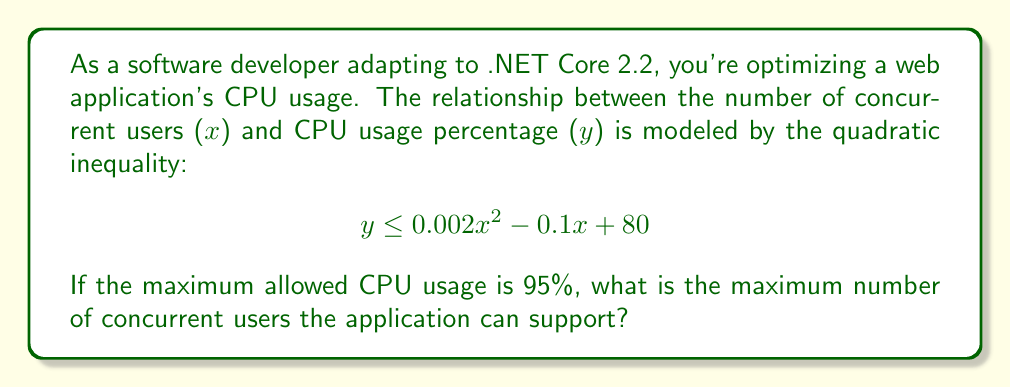Could you help me with this problem? To solve this problem, we need to follow these steps:

1) We're looking for the maximum value of x that satisfies the inequality when y = 95 (maximum CPU usage). So we can rewrite the inequality as an equation:

   $$ 95 = 0.002x^2 - 0.1x + 80 $$

2) Rearrange the equation to standard form:

   $$ 0.002x^2 - 0.1x - 15 = 0 $$

3) This is a quadratic equation. We can solve it using the quadratic formula:

   $$ x = \frac{-b \pm \sqrt{b^2 - 4ac}}{2a} $$

   Where $a = 0.002$, $b = -0.1$, and $c = -15$

4) Substituting these values:

   $$ x = \frac{0.1 \pm \sqrt{(-0.1)^2 - 4(0.002)(-15)}}{2(0.002)} $$

5) Simplify:

   $$ x = \frac{0.1 \pm \sqrt{0.01 + 0.12}}{0.004} = \frac{0.1 \pm \sqrt{0.13}}{0.004} $$

6) Calculate:

   $$ x \approx \frac{0.1 \pm 0.3606}{0.004} $$

7) This gives us two solutions:

   $$ x \approx 115.15 \text{ or } -65.15 $$

8) Since we're dealing with number of users, we can discard the negative solution.

9) As we're looking for the maximum number of users, we round down to the nearest whole number.
Answer: 115 users 